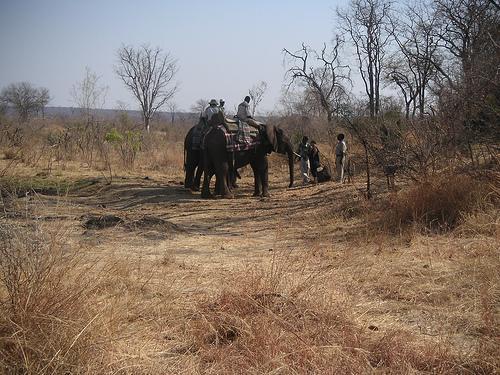How many elephants are in the photo?
Give a very brief answer. 2. How many human beings are in the picture?
Give a very brief answer. 6. How many elephants are visible?
Give a very brief answer. 2. How many people are in the photo?
Give a very brief answer. 6. How many people are sitting on the elephants?
Give a very brief answer. 3. How many people are wearing hats?
Give a very brief answer. 2. 